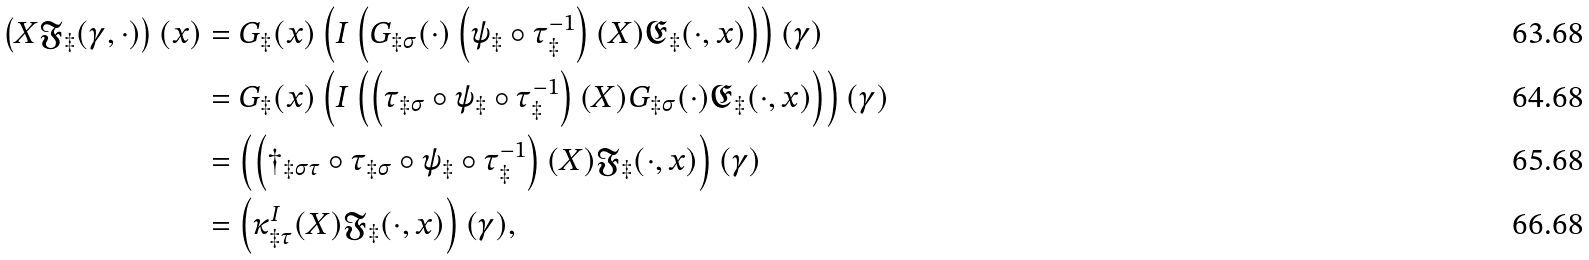Convert formula to latex. <formula><loc_0><loc_0><loc_500><loc_500>\left ( X \mathfrak { F } _ { \ddagger } ( \gamma , \cdot ) \right ) ( x ) & = G _ { \ddagger } ( x ) \left ( I \left ( G _ { \ddagger \sigma } ( \cdot ) \left ( \psi _ { \ddagger } \circ \tau _ { \ddagger } ^ { - 1 } \right ) ( X ) \mathfrak { E } _ { \ddagger } ( \cdot , x ) \right ) \right ) ( \gamma ) \\ & = G _ { \ddagger } ( x ) \left ( I \left ( \left ( \tau _ { \ddagger \sigma } \circ \psi _ { \ddagger } \circ \tau _ { \ddagger } ^ { - 1 } \right ) ( X ) G _ { \ddagger \sigma } ( \cdot ) \mathfrak { E } _ { \ddagger } ( \cdot , x ) \right ) \right ) ( \gamma ) \\ & = \left ( \left ( \dagger _ { \ddagger \sigma \tau } \circ \tau _ { \ddagger \sigma } \circ \psi _ { \ddagger } \circ \tau _ { \ddagger } ^ { - 1 } \right ) ( X ) \mathfrak { F } _ { \ddagger } ( \cdot , x ) \right ) ( \gamma ) \\ & = \left ( \kappa _ { \ddagger \tau } ^ { I } ( X ) \mathfrak { F } _ { \ddagger } ( \cdot , x ) \right ) ( \gamma ) ,</formula> 